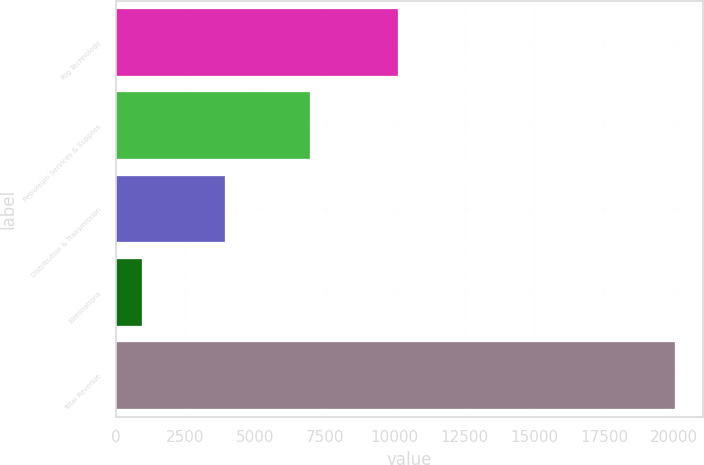Convert chart. <chart><loc_0><loc_0><loc_500><loc_500><bar_chart><fcel>Rig Technology<fcel>Petroleum Services & Supplies<fcel>Distribution & Transmission<fcel>Eliminations<fcel>Total Revenue<nl><fcel>10107<fcel>6967<fcel>3927<fcel>960<fcel>20041<nl></chart> 